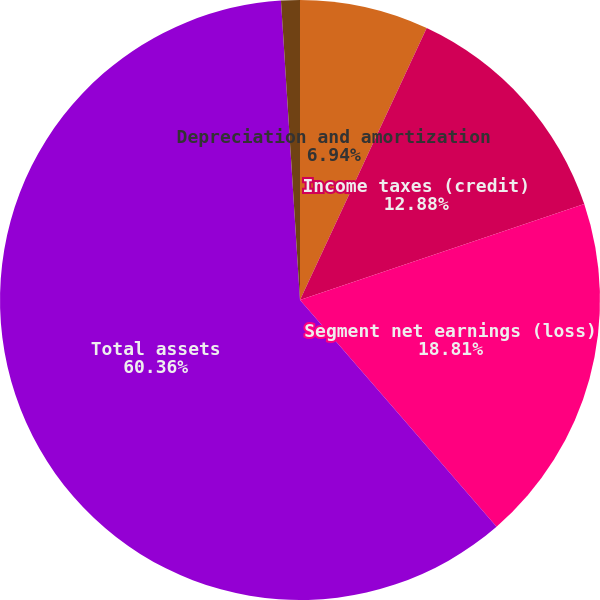<chart> <loc_0><loc_0><loc_500><loc_500><pie_chart><fcel>Depreciation and amortization<fcel>Income taxes (credit)<fcel>Segment net earnings (loss)<fcel>Total assets<fcel>Purchases of property plant<nl><fcel>6.94%<fcel>12.88%<fcel>18.81%<fcel>60.36%<fcel>1.01%<nl></chart> 